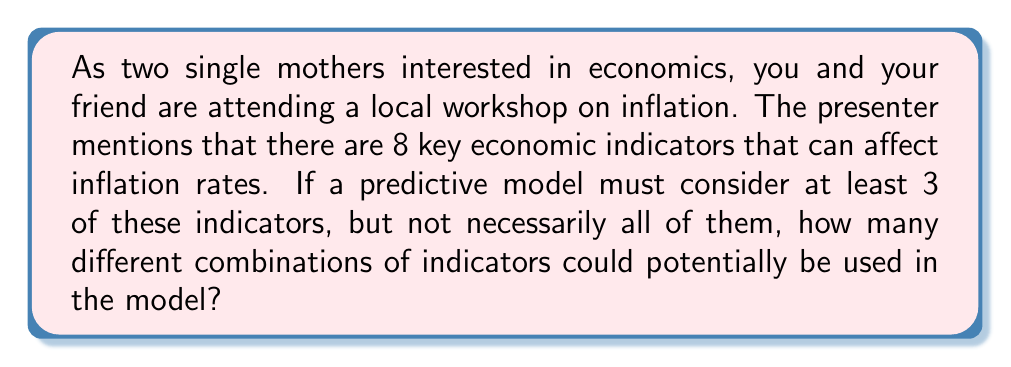Can you answer this question? Let's approach this step-by-step:

1) We have 8 total indicators to choose from.

2) We need to select at least 3 indicators, but could select up to all 8.

3) This means we need to sum up the number of combinations for selecting 3, 4, 5, 6, 7, and 8 indicators out of 8.

4) We can use the combination formula for each of these:

   $$\binom{8}{3} + \binom{8}{4} + \binom{8}{5} + \binom{8}{6} + \binom{8}{7} + \binom{8}{8}$$

5) Let's calculate each of these:

   $$\binom{8}{3} = \frac{8!}{3!(8-3)!} = \frac{8!}{3!5!} = 56$$
   $$\binom{8}{4} = \frac{8!}{4!(8-4)!} = \frac{8!}{4!4!} = 70$$
   $$\binom{8}{5} = \frac{8!}{5!(8-5)!} = \frac{8!}{5!3!} = 56$$
   $$\binom{8}{6} = \frac{8!}{6!(8-6)!} = \frac{8!}{6!2!} = 28$$
   $$\binom{8}{7} = \frac{8!}{7!(8-7)!} = \frac{8!}{7!1!} = 8$$
   $$\binom{8}{8} = \frac{8!}{8!(8-8)!} = \frac{8!}{8!0!} = 1$$

6) Now we sum all these values:

   $$56 + 70 + 56 + 28 + 8 + 1 = 219$$

Therefore, there are 219 different possible combinations of indicators that could be used in the model.
Answer: 219 combinations 